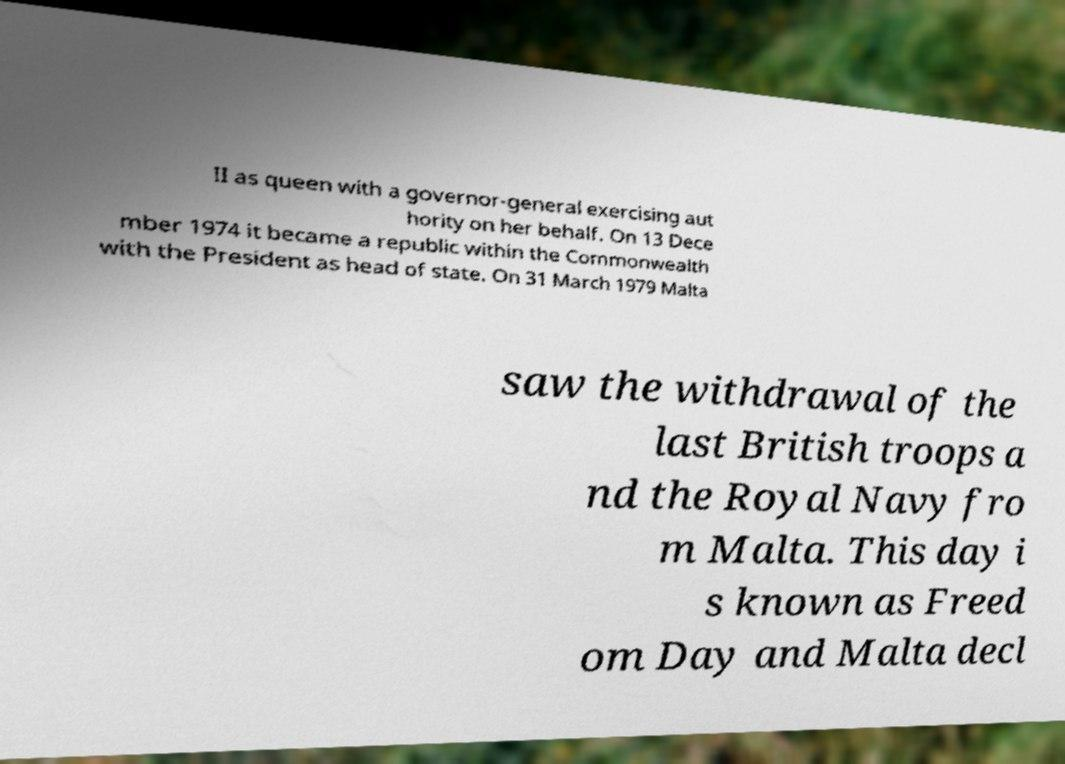Can you accurately transcribe the text from the provided image for me? II as queen with a governor-general exercising aut hority on her behalf. On 13 Dece mber 1974 it became a republic within the Commonwealth with the President as head of state. On 31 March 1979 Malta saw the withdrawal of the last British troops a nd the Royal Navy fro m Malta. This day i s known as Freed om Day and Malta decl 